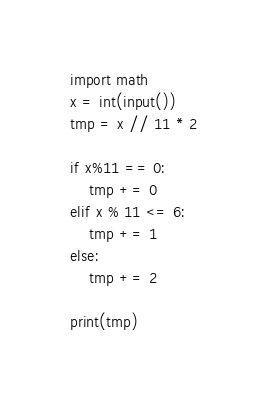<code> <loc_0><loc_0><loc_500><loc_500><_Python_>import math
x = int(input())
tmp = x // 11 * 2

if x%11 == 0:
    tmp += 0
elif x % 11 <= 6:
    tmp += 1
else:
    tmp += 2

print(tmp)
</code> 